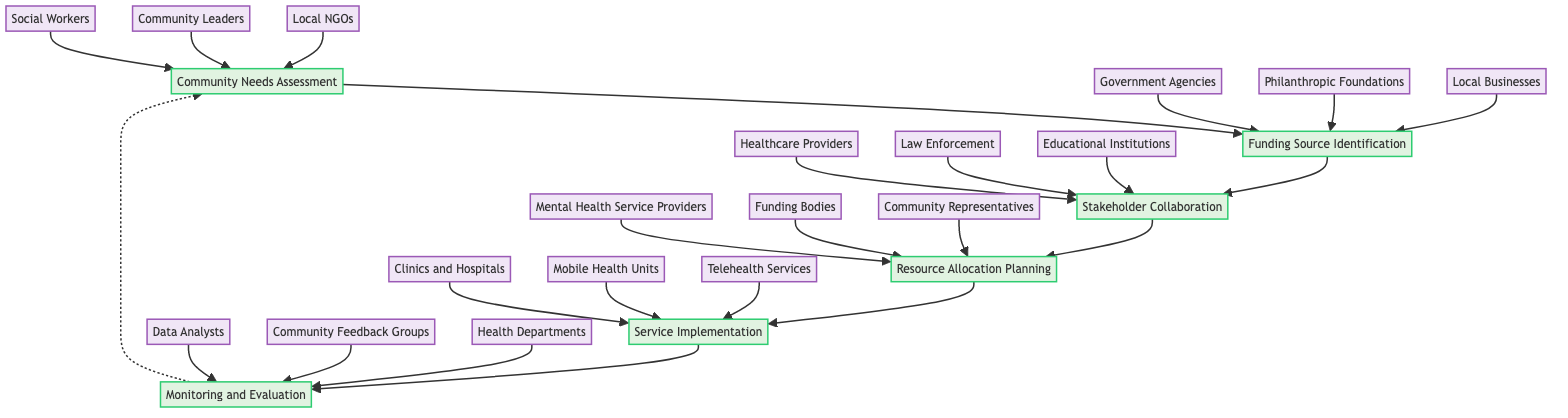What is the first step in the resource allocation process? The first step in the process is represented by the top node labeled "Community Needs Assessment." This is the starting point of the flowchart and indicates that assessing community needs is the initial task.
Answer: Community Needs Assessment How many entities are involved in the "Funding Source Identification" step? The "Funding Source Identification" node has three entities associated with it: "Government Agencies," "Philanthropic Foundations," and "Local Businesses." This requires counting the connected entities.
Answer: 3 Which step follows "Stakeholder Collaboration"? In the flowchart, "Stakeholder Collaboration" is represented by the node that directly leads to the next node, which is "Resource Allocation Planning." This is determined by following the directional arrow from C to D.
Answer: Resource Allocation Planning What are the main entities involved in the "Service Implementation" stage? The "Service Implementation" node lists three entities: "Clinics and Hospitals," "Mobile Health Units," and "Telehealth Services." This requires referencing the labels connected to the Service Implementation node.
Answer: Clinics and Hospitals, Mobile Health Units, Telehealth Services Which step includes "Health Departments" as an entity? The entity "Health Departments" is associated with the "Monitoring and Evaluation" step. Identifying the node makes it clear that this is the correct step by looking at the connections to the entities.
Answer: Monitoring and Evaluation What connects "Monitoring and Evaluation" back to the beginning? The "Monitoring and Evaluation" step has a dashed line leading back to the "Community Needs Assessment" node, indicating feedback into the assessment phase after evaluation. This is recognized by the dotted line linking F back to A.
Answer: A dashed line How many total steps are in the resource allocation process? By counting each step in the flowchart, we see that there are six distinct nodes, representing six steps in the process, including loops or connections.
Answer: 6 Which step is directly preceded by "Funding Source Identification"? The step that comes directly after "Funding Source Identification" is "Stakeholder Collaboration." This is determined by looking at the flow from node B to node C.
Answer: Stakeholder Collaboration Which entity groups are involved in the "Community Needs Assessment"? The entities involved in this step are "Local NGOs," "Community Leaders," and "Social Workers." This information is collected from the connections to the node labeled "Community Needs Assessment."
Answer: Local NGOs, Community Leaders, Social Workers 